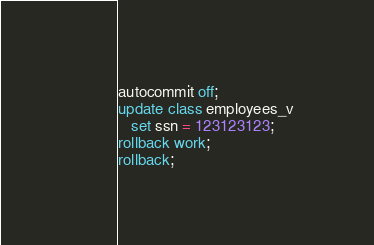<code> <loc_0><loc_0><loc_500><loc_500><_SQL_>autocommit off;
update class employees_v
   set ssn = 123123123;
rollback work;
rollback;
</code> 